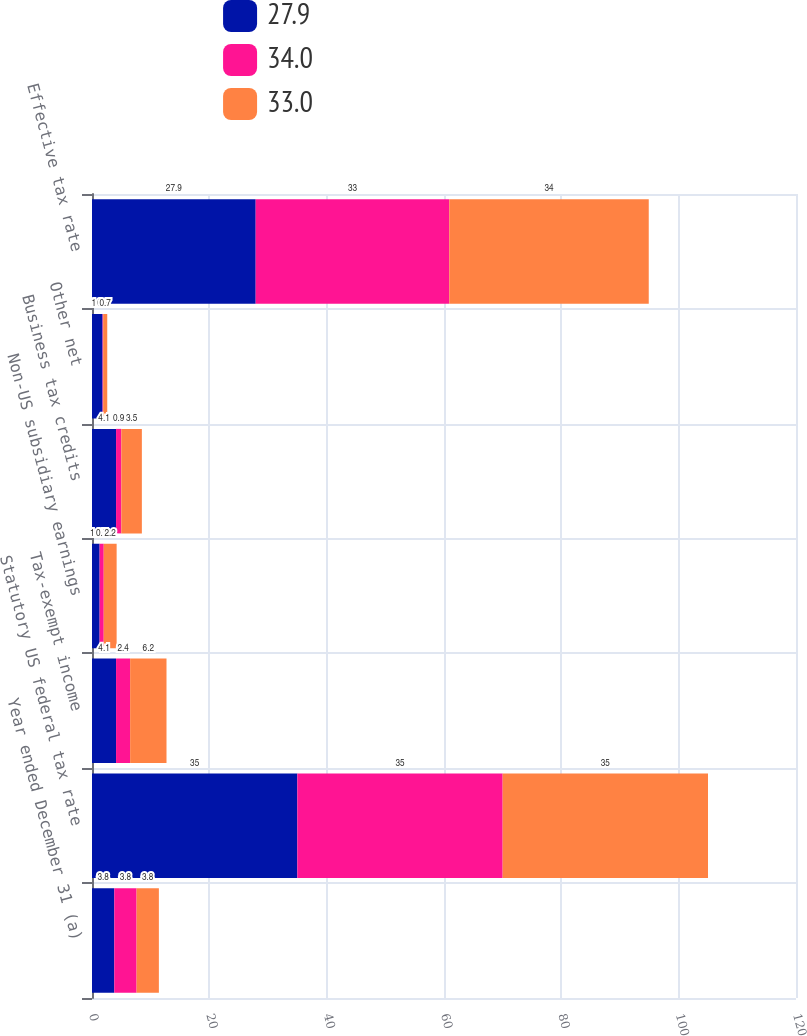Convert chart to OTSL. <chart><loc_0><loc_0><loc_500><loc_500><stacked_bar_chart><ecel><fcel>Year ended December 31 (a)<fcel>Statutory US federal tax rate<fcel>Tax-exempt income<fcel>Non-US subsidiary earnings<fcel>Business tax credits<fcel>Other net<fcel>Effective tax rate<nl><fcel>27.9<fcel>3.8<fcel>35<fcel>4.1<fcel>1.3<fcel>4.1<fcel>1.8<fcel>27.9<nl><fcel>34<fcel>3.8<fcel>35<fcel>2.4<fcel>0.7<fcel>0.9<fcel>0.1<fcel>33<nl><fcel>33<fcel>3.8<fcel>35<fcel>6.2<fcel>2.2<fcel>3.5<fcel>0.7<fcel>34<nl></chart> 